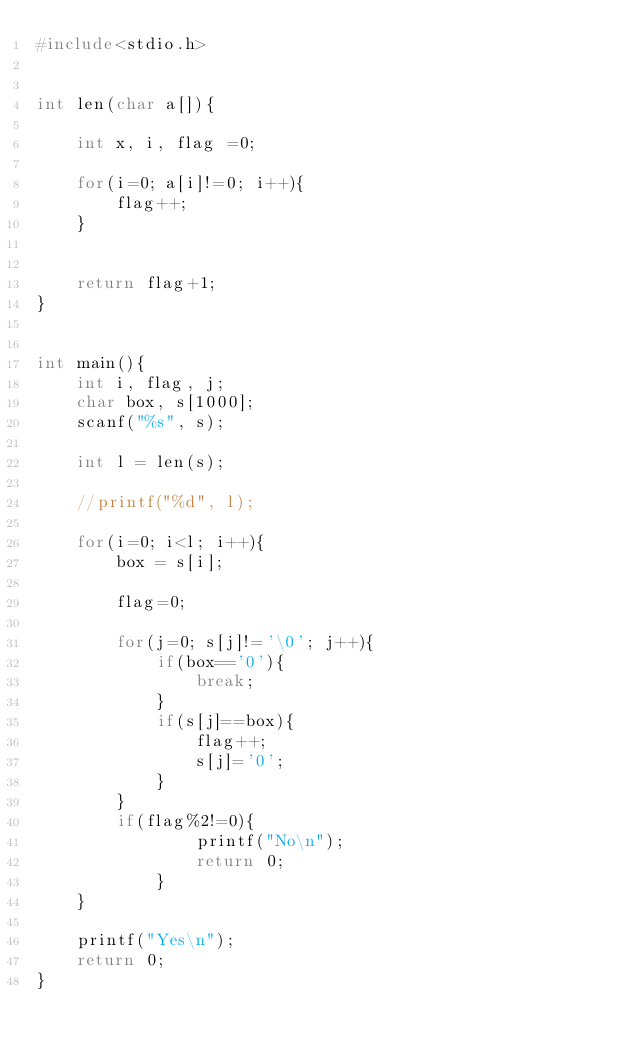<code> <loc_0><loc_0><loc_500><loc_500><_C_>#include<stdio.h>


int len(char a[]){
	
	int x, i, flag =0;
	
	for(i=0; a[i]!=0; i++){
		flag++;
	}
	
	
	return flag+1;
}


int main(){
	int i, flag, j; 
	char box, s[1000];
	scanf("%s", s);
	
	int l = len(s);
	
	//printf("%d", l);
	
	for(i=0; i<l; i++){
		box = s[i];
		
		flag=0;
		
		for(j=0; s[j]!='\0'; j++){
			if(box=='0'){
				break;
			}
			if(s[j]==box){
				flag++;
				s[j]='0';
			}	
		}	
		if(flag%2!=0){
				printf("No\n");
				return 0;
			}	
	}
	
	printf("Yes\n");
	return 0;
}</code> 